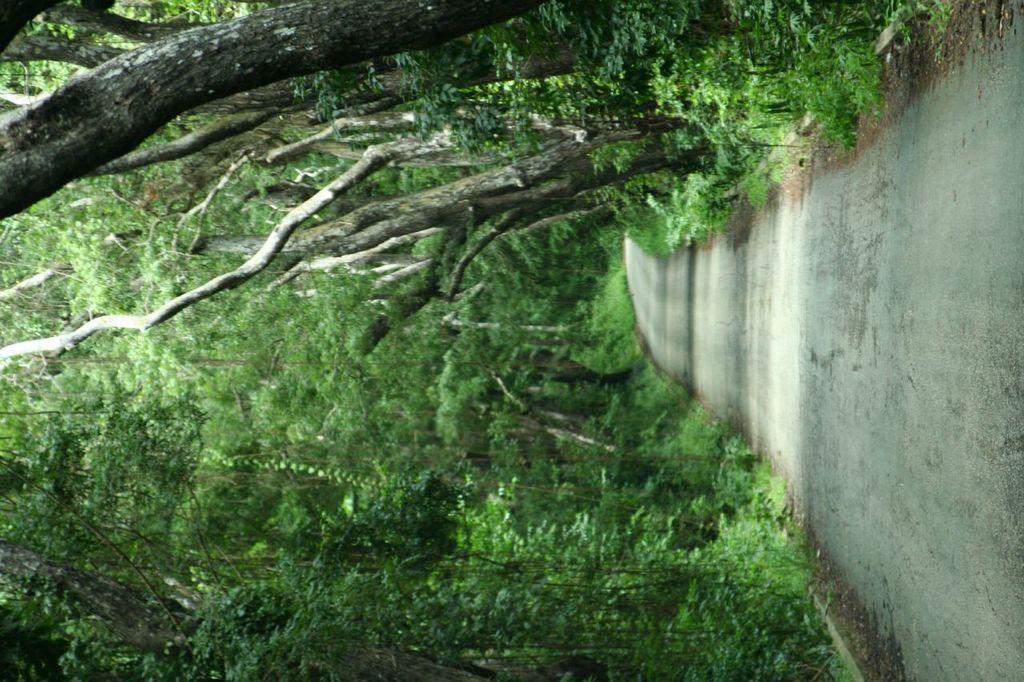Can you describe this image briefly? There is a road and there are trees on either sides of it. 